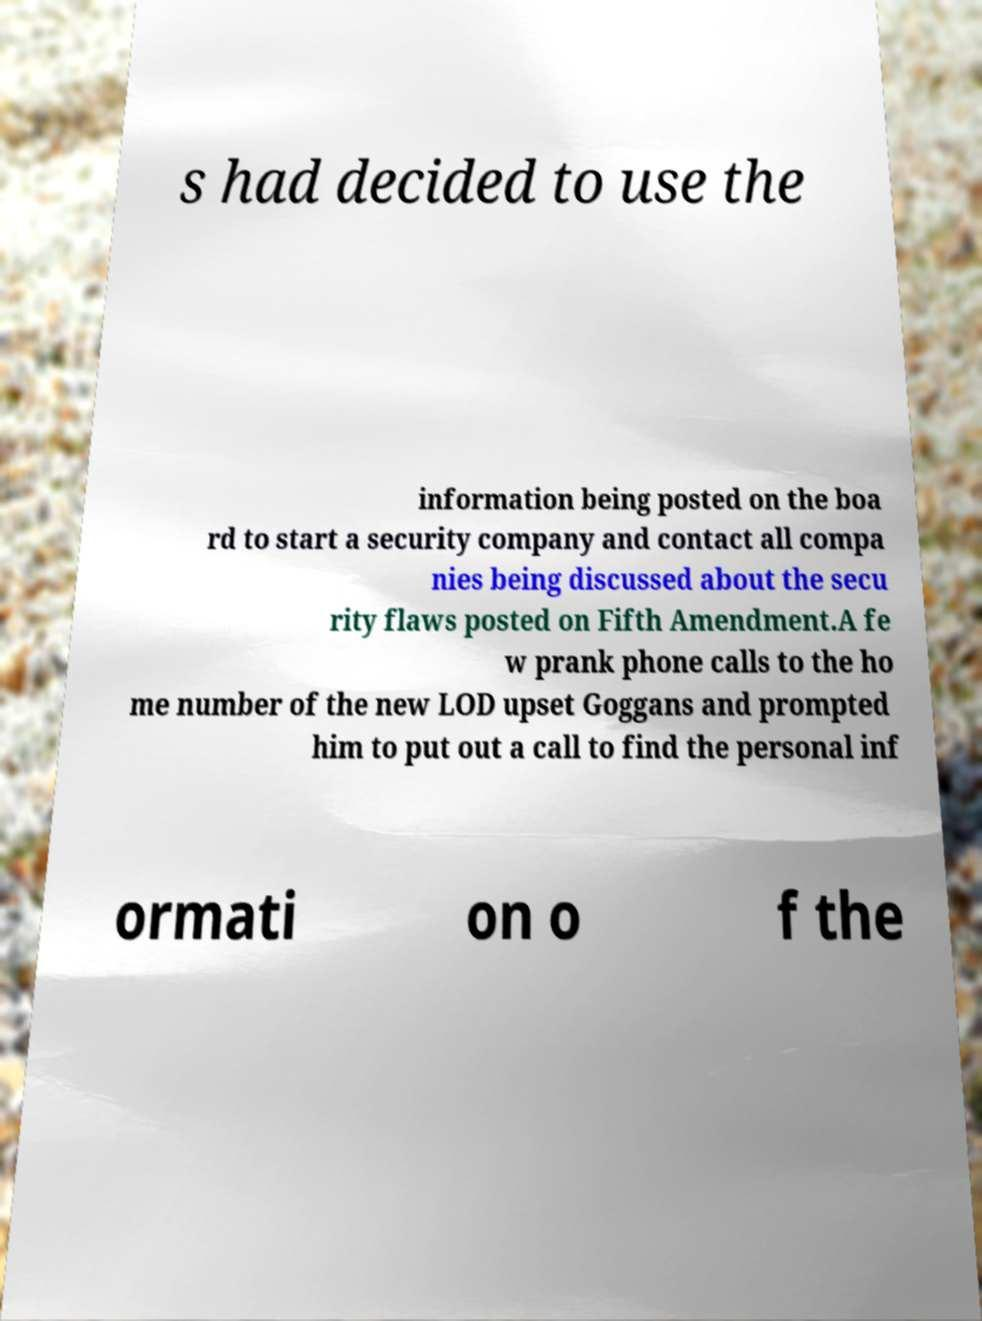Please identify and transcribe the text found in this image. s had decided to use the information being posted on the boa rd to start a security company and contact all compa nies being discussed about the secu rity flaws posted on Fifth Amendment.A fe w prank phone calls to the ho me number of the new LOD upset Goggans and prompted him to put out a call to find the personal inf ormati on o f the 